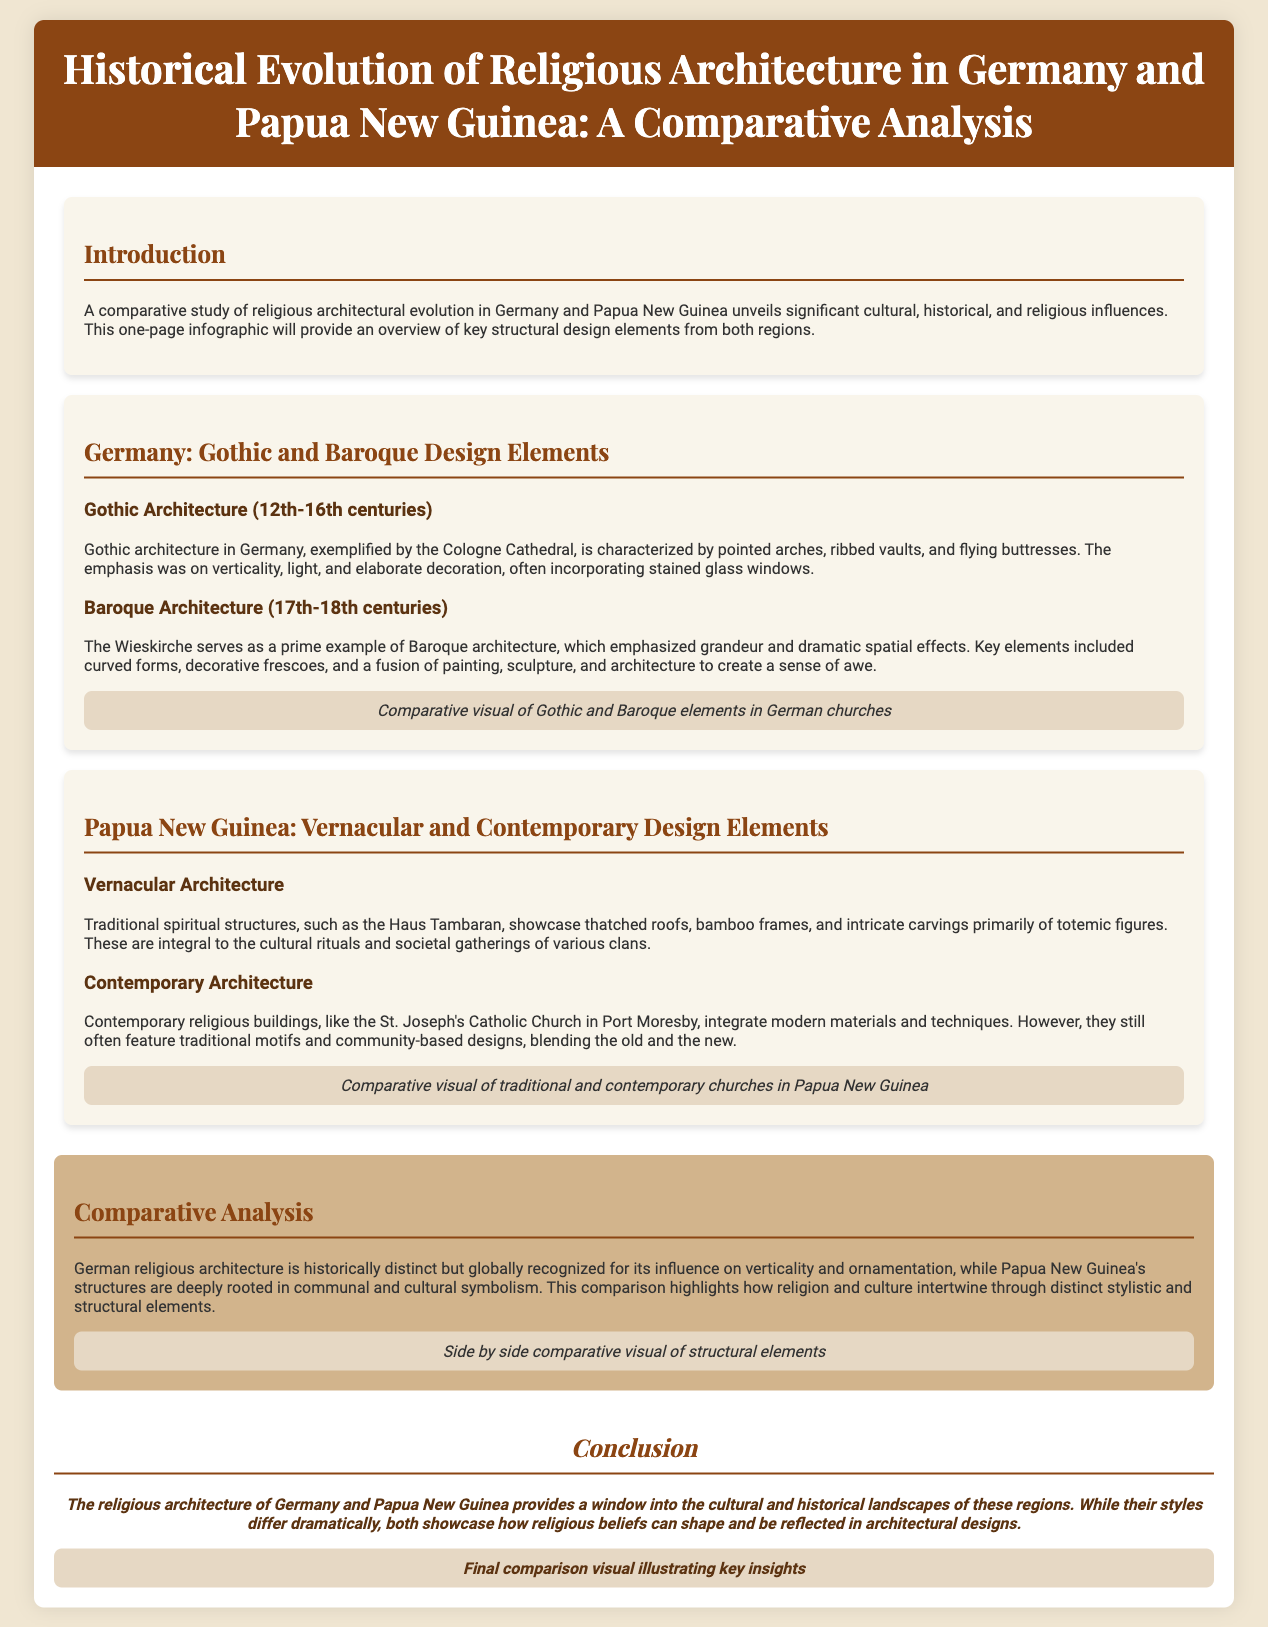What are the main architectural styles discussed for Germany? The document mentions Gothic and Baroque as the main architectural styles for Germany.
Answer: Gothic and Baroque What is the name of the example Gothic architecture in Germany? The example provided for Gothic architecture is the Cologne Cathedral.
Answer: Cologne Cathedral What type of roof is characteristic of the Haus Tambaran in Papua New Guinea? The Haus Tambaran features thatched roofs, which are typical in vernacular architecture.
Answer: Thatched roofs Which religious building represents Baroque architecture? The Wieskirche is highlighted as a prime example of Baroque architecture.
Answer: Wieskirche What design elements are emphasized in contemporary architecture in Papua New Guinea? Contemporary architecture integrates modern materials but often features traditional motifs.
Answer: Modern materials and traditional motifs How do German and Papua New Guinea's religious architecture compare? The comparison emphasizes the distinct historical influences on German architecture versus the communal symbolism in Papua New Guinea's structures.
Answer: Historical influences and communal symbolism What is the focus of the introduction section? The introduction outlines the significant cultural, historical, and religious influences on the architectural evolution in both regions.
Answer: Cultural, historical, and religious influences What does the conclusion indicate about the styles of the two regions? The conclusion indicates that despite the dramatic differences in styles, both reflect how religious beliefs shape architectural designs.
Answer: Reflecting religious beliefs What did the visual elements compare in the infographic? The visuals compare Gothic and Baroque elements in German churches with traditional and contemporary churches in Papua New Guinea.
Answer: Gothic and Baroque vs. traditional and contemporary 